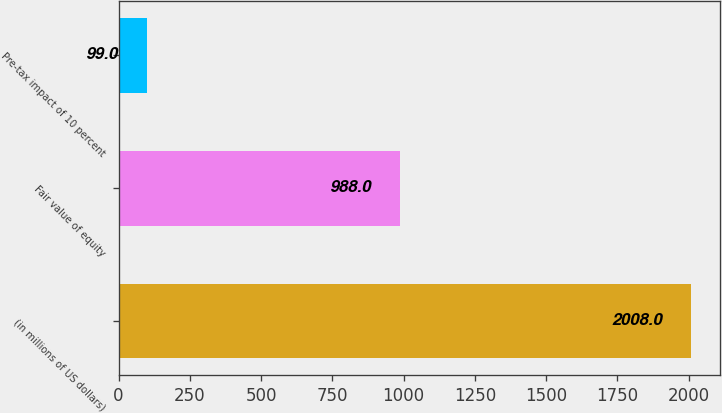<chart> <loc_0><loc_0><loc_500><loc_500><bar_chart><fcel>(in millions of US dollars)<fcel>Fair value of equity<fcel>Pre-tax impact of 10 percent<nl><fcel>2008<fcel>988<fcel>99<nl></chart> 